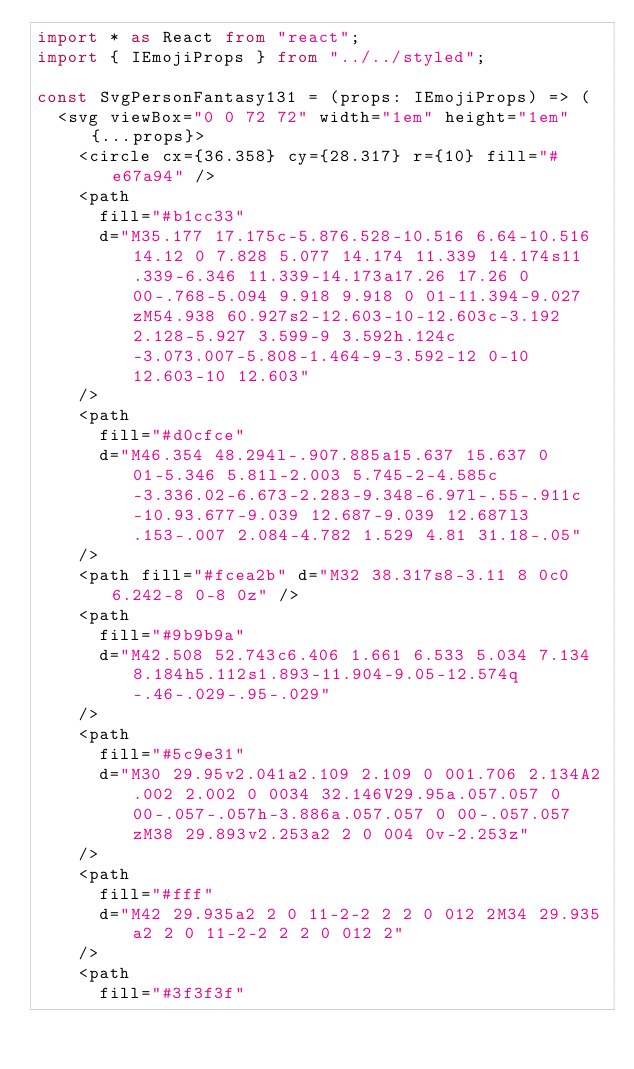<code> <loc_0><loc_0><loc_500><loc_500><_TypeScript_>import * as React from "react";
import { IEmojiProps } from "../../styled";

const SvgPersonFantasy131 = (props: IEmojiProps) => (
  <svg viewBox="0 0 72 72" width="1em" height="1em" {...props}>
    <circle cx={36.358} cy={28.317} r={10} fill="#e67a94" />
    <path
      fill="#b1cc33"
      d="M35.177 17.175c-5.876.528-10.516 6.64-10.516 14.12 0 7.828 5.077 14.174 11.339 14.174s11.339-6.346 11.339-14.173a17.26 17.26 0 00-.768-5.094 9.918 9.918 0 01-11.394-9.027zM54.938 60.927s2-12.603-10-12.603c-3.192 2.128-5.927 3.599-9 3.592h.124c-3.073.007-5.808-1.464-9-3.592-12 0-10 12.603-10 12.603"
    />
    <path
      fill="#d0cfce"
      d="M46.354 48.294l-.907.885a15.637 15.637 0 01-5.346 5.81l-2.003 5.745-2-4.585c-3.336.02-6.673-2.283-9.348-6.97l-.55-.911c-10.93.677-9.039 12.687-9.039 12.687l3.153-.007 2.084-4.782 1.529 4.81 31.18-.05"
    />
    <path fill="#fcea2b" d="M32 38.317s8-3.11 8 0c0 6.242-8 0-8 0z" />
    <path
      fill="#9b9b9a"
      d="M42.508 52.743c6.406 1.661 6.533 5.034 7.134 8.184h5.112s1.893-11.904-9.05-12.574q-.46-.029-.95-.029"
    />
    <path
      fill="#5c9e31"
      d="M30 29.95v2.041a2.109 2.109 0 001.706 2.134A2.002 2.002 0 0034 32.146V29.95a.057.057 0 00-.057-.057h-3.886a.057.057 0 00-.057.057zM38 29.893v2.253a2 2 0 004 0v-2.253z"
    />
    <path
      fill="#fff"
      d="M42 29.935a2 2 0 11-2-2 2 2 0 012 2M34 29.935a2 2 0 11-2-2 2 2 0 012 2"
    />
    <path
      fill="#3f3f3f"</code> 